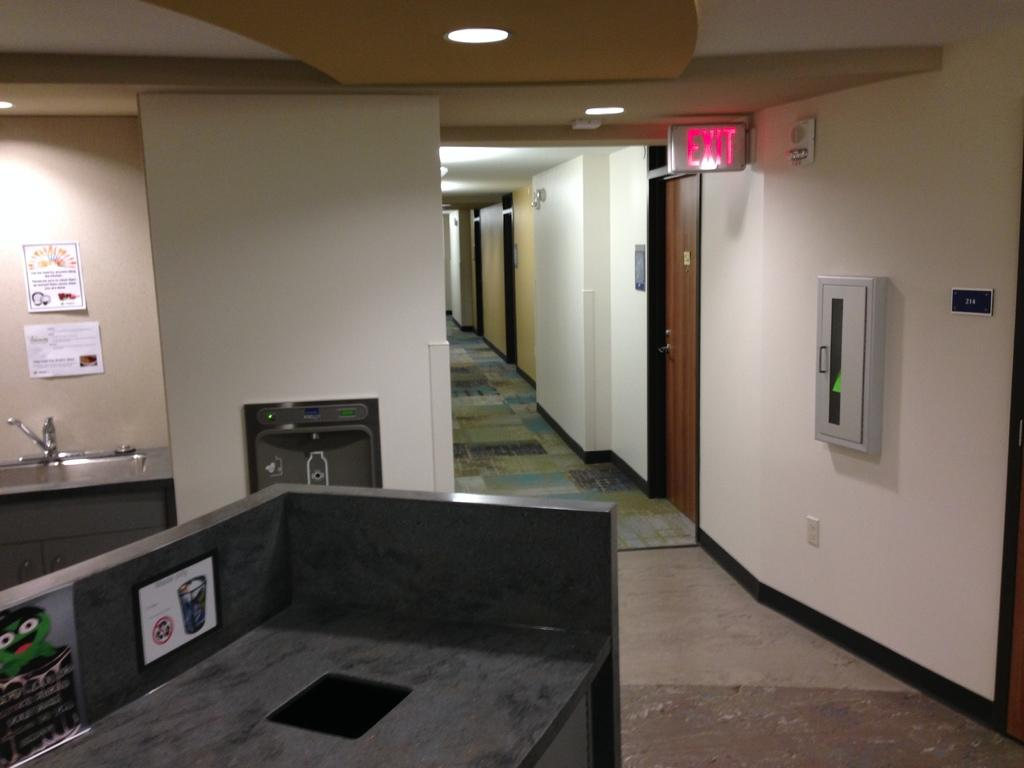<image>
Write a terse but informative summary of the picture. An office area showing an exit sign lit up in red 